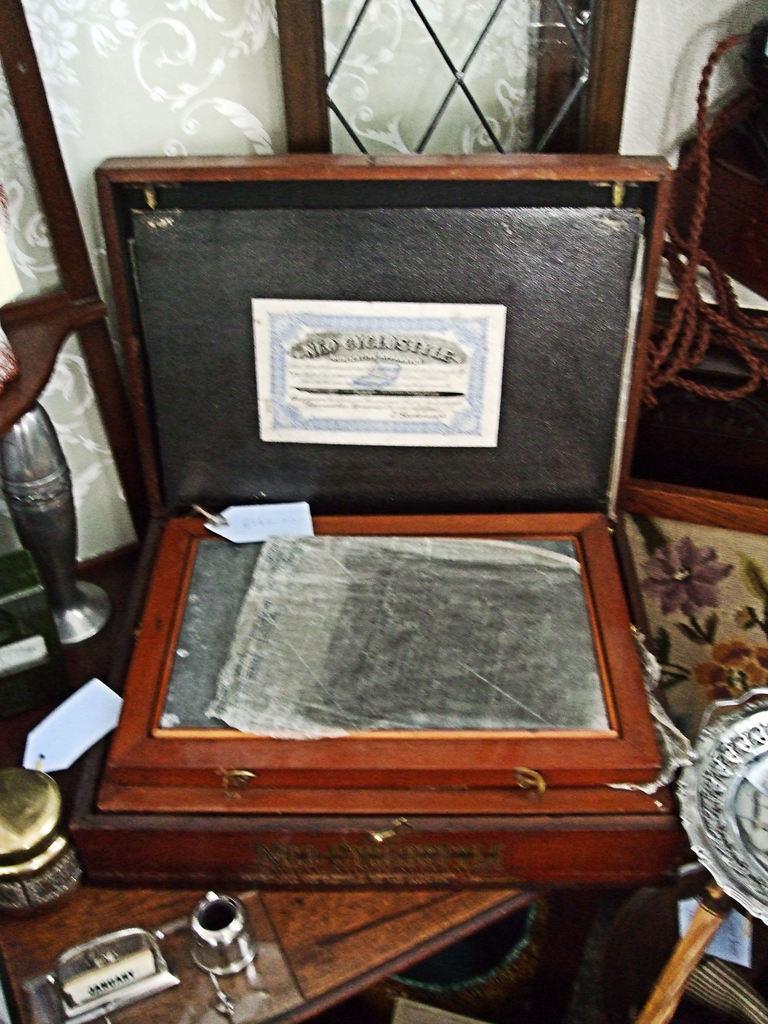How would you summarize this image in a sentence or two? Here we can see a suitcase which is kept on this wooden table. 